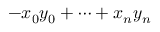Convert formula to latex. <formula><loc_0><loc_0><loc_500><loc_500>- x _ { 0 } y _ { 0 } + \cdots + x _ { n } y _ { n }</formula> 